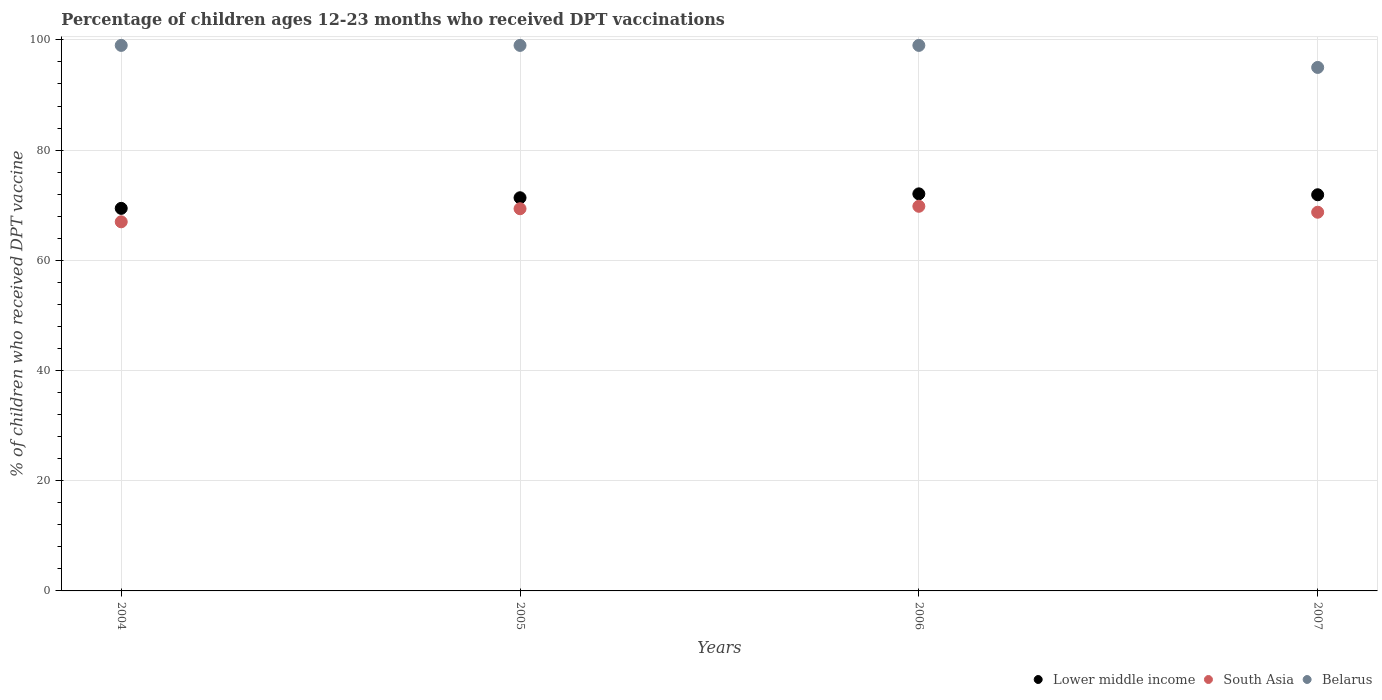What is the percentage of children who received DPT vaccination in South Asia in 2007?
Ensure brevity in your answer.  68.72. Across all years, what is the maximum percentage of children who received DPT vaccination in South Asia?
Offer a terse response. 69.8. Across all years, what is the minimum percentage of children who received DPT vaccination in Belarus?
Your answer should be very brief. 95. In which year was the percentage of children who received DPT vaccination in Lower middle income maximum?
Offer a terse response. 2006. In which year was the percentage of children who received DPT vaccination in South Asia minimum?
Give a very brief answer. 2004. What is the total percentage of children who received DPT vaccination in South Asia in the graph?
Offer a very short reply. 274.87. What is the difference between the percentage of children who received DPT vaccination in Lower middle income in 2005 and that in 2007?
Keep it short and to the point. -0.54. What is the difference between the percentage of children who received DPT vaccination in Lower middle income in 2006 and the percentage of children who received DPT vaccination in Belarus in 2004?
Your answer should be compact. -26.94. In the year 2004, what is the difference between the percentage of children who received DPT vaccination in Lower middle income and percentage of children who received DPT vaccination in Belarus?
Provide a short and direct response. -29.58. What is the ratio of the percentage of children who received DPT vaccination in South Asia in 2005 to that in 2007?
Offer a very short reply. 1.01. Is the percentage of children who received DPT vaccination in South Asia in 2004 less than that in 2005?
Give a very brief answer. Yes. Is the difference between the percentage of children who received DPT vaccination in Lower middle income in 2005 and 2007 greater than the difference between the percentage of children who received DPT vaccination in Belarus in 2005 and 2007?
Your answer should be compact. No. What is the difference between the highest and the second highest percentage of children who received DPT vaccination in Lower middle income?
Give a very brief answer. 0.16. In how many years, is the percentage of children who received DPT vaccination in South Asia greater than the average percentage of children who received DPT vaccination in South Asia taken over all years?
Your response must be concise. 3. Is the sum of the percentage of children who received DPT vaccination in Belarus in 2004 and 2007 greater than the maximum percentage of children who received DPT vaccination in South Asia across all years?
Your response must be concise. Yes. Is it the case that in every year, the sum of the percentage of children who received DPT vaccination in South Asia and percentage of children who received DPT vaccination in Lower middle income  is greater than the percentage of children who received DPT vaccination in Belarus?
Offer a terse response. Yes. Does the percentage of children who received DPT vaccination in Belarus monotonically increase over the years?
Provide a succinct answer. No. Is the percentage of children who received DPT vaccination in Lower middle income strictly greater than the percentage of children who received DPT vaccination in Belarus over the years?
Your answer should be compact. No. Is the percentage of children who received DPT vaccination in South Asia strictly less than the percentage of children who received DPT vaccination in Lower middle income over the years?
Ensure brevity in your answer.  Yes. How many dotlines are there?
Provide a succinct answer. 3. What is the difference between two consecutive major ticks on the Y-axis?
Ensure brevity in your answer.  20. Are the values on the major ticks of Y-axis written in scientific E-notation?
Give a very brief answer. No. Does the graph contain any zero values?
Provide a succinct answer. No. Where does the legend appear in the graph?
Give a very brief answer. Bottom right. How many legend labels are there?
Provide a short and direct response. 3. How are the legend labels stacked?
Offer a very short reply. Horizontal. What is the title of the graph?
Make the answer very short. Percentage of children ages 12-23 months who received DPT vaccinations. What is the label or title of the X-axis?
Your answer should be compact. Years. What is the label or title of the Y-axis?
Your answer should be compact. % of children who received DPT vaccine. What is the % of children who received DPT vaccine in Lower middle income in 2004?
Offer a terse response. 69.42. What is the % of children who received DPT vaccine of South Asia in 2004?
Your response must be concise. 66.99. What is the % of children who received DPT vaccine of Lower middle income in 2005?
Provide a short and direct response. 71.35. What is the % of children who received DPT vaccine of South Asia in 2005?
Keep it short and to the point. 69.36. What is the % of children who received DPT vaccine in Lower middle income in 2006?
Offer a terse response. 72.06. What is the % of children who received DPT vaccine in South Asia in 2006?
Offer a very short reply. 69.8. What is the % of children who received DPT vaccine of Lower middle income in 2007?
Provide a short and direct response. 71.89. What is the % of children who received DPT vaccine of South Asia in 2007?
Ensure brevity in your answer.  68.72. What is the % of children who received DPT vaccine of Belarus in 2007?
Make the answer very short. 95. Across all years, what is the maximum % of children who received DPT vaccine of Lower middle income?
Give a very brief answer. 72.06. Across all years, what is the maximum % of children who received DPT vaccine in South Asia?
Your answer should be very brief. 69.8. Across all years, what is the maximum % of children who received DPT vaccine in Belarus?
Your answer should be compact. 99. Across all years, what is the minimum % of children who received DPT vaccine in Lower middle income?
Your answer should be compact. 69.42. Across all years, what is the minimum % of children who received DPT vaccine in South Asia?
Offer a terse response. 66.99. What is the total % of children who received DPT vaccine of Lower middle income in the graph?
Your response must be concise. 284.73. What is the total % of children who received DPT vaccine of South Asia in the graph?
Your answer should be very brief. 274.87. What is the total % of children who received DPT vaccine in Belarus in the graph?
Your answer should be compact. 392. What is the difference between the % of children who received DPT vaccine of Lower middle income in 2004 and that in 2005?
Your answer should be compact. -1.93. What is the difference between the % of children who received DPT vaccine in South Asia in 2004 and that in 2005?
Offer a very short reply. -2.37. What is the difference between the % of children who received DPT vaccine of Lower middle income in 2004 and that in 2006?
Make the answer very short. -2.63. What is the difference between the % of children who received DPT vaccine of South Asia in 2004 and that in 2006?
Your answer should be compact. -2.82. What is the difference between the % of children who received DPT vaccine in Belarus in 2004 and that in 2006?
Ensure brevity in your answer.  0. What is the difference between the % of children who received DPT vaccine of Lower middle income in 2004 and that in 2007?
Give a very brief answer. -2.47. What is the difference between the % of children who received DPT vaccine in South Asia in 2004 and that in 2007?
Provide a succinct answer. -1.74. What is the difference between the % of children who received DPT vaccine of Belarus in 2004 and that in 2007?
Keep it short and to the point. 4. What is the difference between the % of children who received DPT vaccine in Lower middle income in 2005 and that in 2006?
Keep it short and to the point. -0.71. What is the difference between the % of children who received DPT vaccine in South Asia in 2005 and that in 2006?
Provide a short and direct response. -0.44. What is the difference between the % of children who received DPT vaccine in Belarus in 2005 and that in 2006?
Offer a very short reply. 0. What is the difference between the % of children who received DPT vaccine in Lower middle income in 2005 and that in 2007?
Provide a short and direct response. -0.54. What is the difference between the % of children who received DPT vaccine of South Asia in 2005 and that in 2007?
Offer a terse response. 0.63. What is the difference between the % of children who received DPT vaccine in Belarus in 2005 and that in 2007?
Make the answer very short. 4. What is the difference between the % of children who received DPT vaccine of Lower middle income in 2006 and that in 2007?
Offer a very short reply. 0.16. What is the difference between the % of children who received DPT vaccine in South Asia in 2006 and that in 2007?
Make the answer very short. 1.08. What is the difference between the % of children who received DPT vaccine in Belarus in 2006 and that in 2007?
Your response must be concise. 4. What is the difference between the % of children who received DPT vaccine of Lower middle income in 2004 and the % of children who received DPT vaccine of South Asia in 2005?
Your answer should be very brief. 0.07. What is the difference between the % of children who received DPT vaccine of Lower middle income in 2004 and the % of children who received DPT vaccine of Belarus in 2005?
Keep it short and to the point. -29.58. What is the difference between the % of children who received DPT vaccine of South Asia in 2004 and the % of children who received DPT vaccine of Belarus in 2005?
Offer a terse response. -32.01. What is the difference between the % of children who received DPT vaccine of Lower middle income in 2004 and the % of children who received DPT vaccine of South Asia in 2006?
Your response must be concise. -0.38. What is the difference between the % of children who received DPT vaccine in Lower middle income in 2004 and the % of children who received DPT vaccine in Belarus in 2006?
Provide a succinct answer. -29.58. What is the difference between the % of children who received DPT vaccine of South Asia in 2004 and the % of children who received DPT vaccine of Belarus in 2006?
Give a very brief answer. -32.01. What is the difference between the % of children who received DPT vaccine in Lower middle income in 2004 and the % of children who received DPT vaccine in South Asia in 2007?
Ensure brevity in your answer.  0.7. What is the difference between the % of children who received DPT vaccine of Lower middle income in 2004 and the % of children who received DPT vaccine of Belarus in 2007?
Your answer should be very brief. -25.58. What is the difference between the % of children who received DPT vaccine in South Asia in 2004 and the % of children who received DPT vaccine in Belarus in 2007?
Make the answer very short. -28.01. What is the difference between the % of children who received DPT vaccine in Lower middle income in 2005 and the % of children who received DPT vaccine in South Asia in 2006?
Provide a succinct answer. 1.55. What is the difference between the % of children who received DPT vaccine of Lower middle income in 2005 and the % of children who received DPT vaccine of Belarus in 2006?
Make the answer very short. -27.65. What is the difference between the % of children who received DPT vaccine in South Asia in 2005 and the % of children who received DPT vaccine in Belarus in 2006?
Keep it short and to the point. -29.64. What is the difference between the % of children who received DPT vaccine in Lower middle income in 2005 and the % of children who received DPT vaccine in South Asia in 2007?
Give a very brief answer. 2.63. What is the difference between the % of children who received DPT vaccine of Lower middle income in 2005 and the % of children who received DPT vaccine of Belarus in 2007?
Provide a short and direct response. -23.65. What is the difference between the % of children who received DPT vaccine in South Asia in 2005 and the % of children who received DPT vaccine in Belarus in 2007?
Provide a short and direct response. -25.64. What is the difference between the % of children who received DPT vaccine of Lower middle income in 2006 and the % of children who received DPT vaccine of South Asia in 2007?
Provide a short and direct response. 3.33. What is the difference between the % of children who received DPT vaccine of Lower middle income in 2006 and the % of children who received DPT vaccine of Belarus in 2007?
Ensure brevity in your answer.  -22.94. What is the difference between the % of children who received DPT vaccine of South Asia in 2006 and the % of children who received DPT vaccine of Belarus in 2007?
Keep it short and to the point. -25.2. What is the average % of children who received DPT vaccine of Lower middle income per year?
Make the answer very short. 71.18. What is the average % of children who received DPT vaccine of South Asia per year?
Offer a terse response. 68.72. In the year 2004, what is the difference between the % of children who received DPT vaccine in Lower middle income and % of children who received DPT vaccine in South Asia?
Offer a very short reply. 2.44. In the year 2004, what is the difference between the % of children who received DPT vaccine in Lower middle income and % of children who received DPT vaccine in Belarus?
Keep it short and to the point. -29.58. In the year 2004, what is the difference between the % of children who received DPT vaccine in South Asia and % of children who received DPT vaccine in Belarus?
Your answer should be very brief. -32.01. In the year 2005, what is the difference between the % of children who received DPT vaccine of Lower middle income and % of children who received DPT vaccine of South Asia?
Give a very brief answer. 1.99. In the year 2005, what is the difference between the % of children who received DPT vaccine in Lower middle income and % of children who received DPT vaccine in Belarus?
Keep it short and to the point. -27.65. In the year 2005, what is the difference between the % of children who received DPT vaccine of South Asia and % of children who received DPT vaccine of Belarus?
Your response must be concise. -29.64. In the year 2006, what is the difference between the % of children who received DPT vaccine in Lower middle income and % of children who received DPT vaccine in South Asia?
Provide a succinct answer. 2.26. In the year 2006, what is the difference between the % of children who received DPT vaccine of Lower middle income and % of children who received DPT vaccine of Belarus?
Make the answer very short. -26.94. In the year 2006, what is the difference between the % of children who received DPT vaccine in South Asia and % of children who received DPT vaccine in Belarus?
Your response must be concise. -29.2. In the year 2007, what is the difference between the % of children who received DPT vaccine of Lower middle income and % of children who received DPT vaccine of South Asia?
Give a very brief answer. 3.17. In the year 2007, what is the difference between the % of children who received DPT vaccine in Lower middle income and % of children who received DPT vaccine in Belarus?
Offer a very short reply. -23.11. In the year 2007, what is the difference between the % of children who received DPT vaccine in South Asia and % of children who received DPT vaccine in Belarus?
Your response must be concise. -26.28. What is the ratio of the % of children who received DPT vaccine in South Asia in 2004 to that in 2005?
Keep it short and to the point. 0.97. What is the ratio of the % of children who received DPT vaccine in Lower middle income in 2004 to that in 2006?
Your answer should be compact. 0.96. What is the ratio of the % of children who received DPT vaccine in South Asia in 2004 to that in 2006?
Your answer should be very brief. 0.96. What is the ratio of the % of children who received DPT vaccine in Lower middle income in 2004 to that in 2007?
Provide a succinct answer. 0.97. What is the ratio of the % of children who received DPT vaccine in South Asia in 2004 to that in 2007?
Ensure brevity in your answer.  0.97. What is the ratio of the % of children who received DPT vaccine in Belarus in 2004 to that in 2007?
Your response must be concise. 1.04. What is the ratio of the % of children who received DPT vaccine in Lower middle income in 2005 to that in 2006?
Offer a terse response. 0.99. What is the ratio of the % of children who received DPT vaccine in South Asia in 2005 to that in 2006?
Offer a very short reply. 0.99. What is the ratio of the % of children who received DPT vaccine of Belarus in 2005 to that in 2006?
Give a very brief answer. 1. What is the ratio of the % of children who received DPT vaccine in South Asia in 2005 to that in 2007?
Provide a succinct answer. 1.01. What is the ratio of the % of children who received DPT vaccine of Belarus in 2005 to that in 2007?
Your answer should be very brief. 1.04. What is the ratio of the % of children who received DPT vaccine in South Asia in 2006 to that in 2007?
Keep it short and to the point. 1.02. What is the ratio of the % of children who received DPT vaccine in Belarus in 2006 to that in 2007?
Offer a terse response. 1.04. What is the difference between the highest and the second highest % of children who received DPT vaccine of Lower middle income?
Keep it short and to the point. 0.16. What is the difference between the highest and the second highest % of children who received DPT vaccine in South Asia?
Offer a very short reply. 0.44. What is the difference between the highest and the second highest % of children who received DPT vaccine in Belarus?
Provide a succinct answer. 0. What is the difference between the highest and the lowest % of children who received DPT vaccine of Lower middle income?
Provide a succinct answer. 2.63. What is the difference between the highest and the lowest % of children who received DPT vaccine of South Asia?
Provide a short and direct response. 2.82. What is the difference between the highest and the lowest % of children who received DPT vaccine of Belarus?
Your answer should be very brief. 4. 